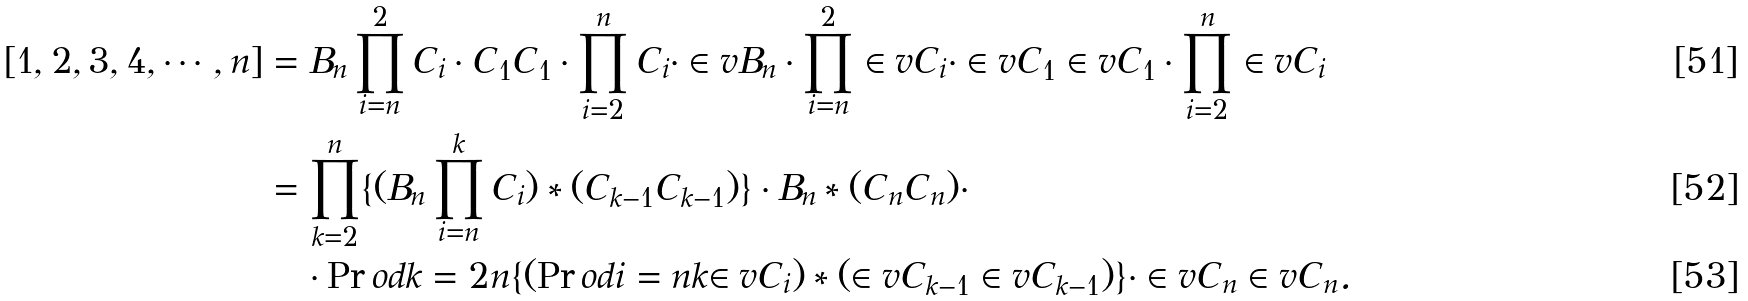<formula> <loc_0><loc_0><loc_500><loc_500>[ 1 , 2 , 3 , 4 , \cdots , n ] & = B _ { n } \prod _ { i = n } ^ { 2 } C _ { i } \cdot C _ { 1 } C _ { 1 } \cdot \prod _ { i = 2 } ^ { n } C _ { i } \cdot \in v { B _ { n } } \cdot \prod _ { i = n } ^ { 2 } \in v { C _ { i } } \cdot \in v { C _ { 1 } } \in v { C _ { 1 } } \cdot \prod _ { i = 2 } ^ { n } \in v { C _ { i } } \\ & = \prod _ { k = 2 } ^ { n } \{ ( B _ { n } \prod _ { i = n } ^ { k } C _ { i } ) * ( C _ { k - 1 } C _ { k - 1 } ) \} \cdot B _ { n } * ( C _ { n } C _ { n } ) \cdot \\ & \quad \cdot \Pr o d { k = 2 } { n } { \{ ( \Pr o d { i = n } { k } { \in v { C _ { i } } } ) * ( \in v { C _ { k - 1 } } \in v { C _ { k - 1 } } ) \} } \cdot \in v { C _ { n } } \in v { C _ { n } } .</formula> 